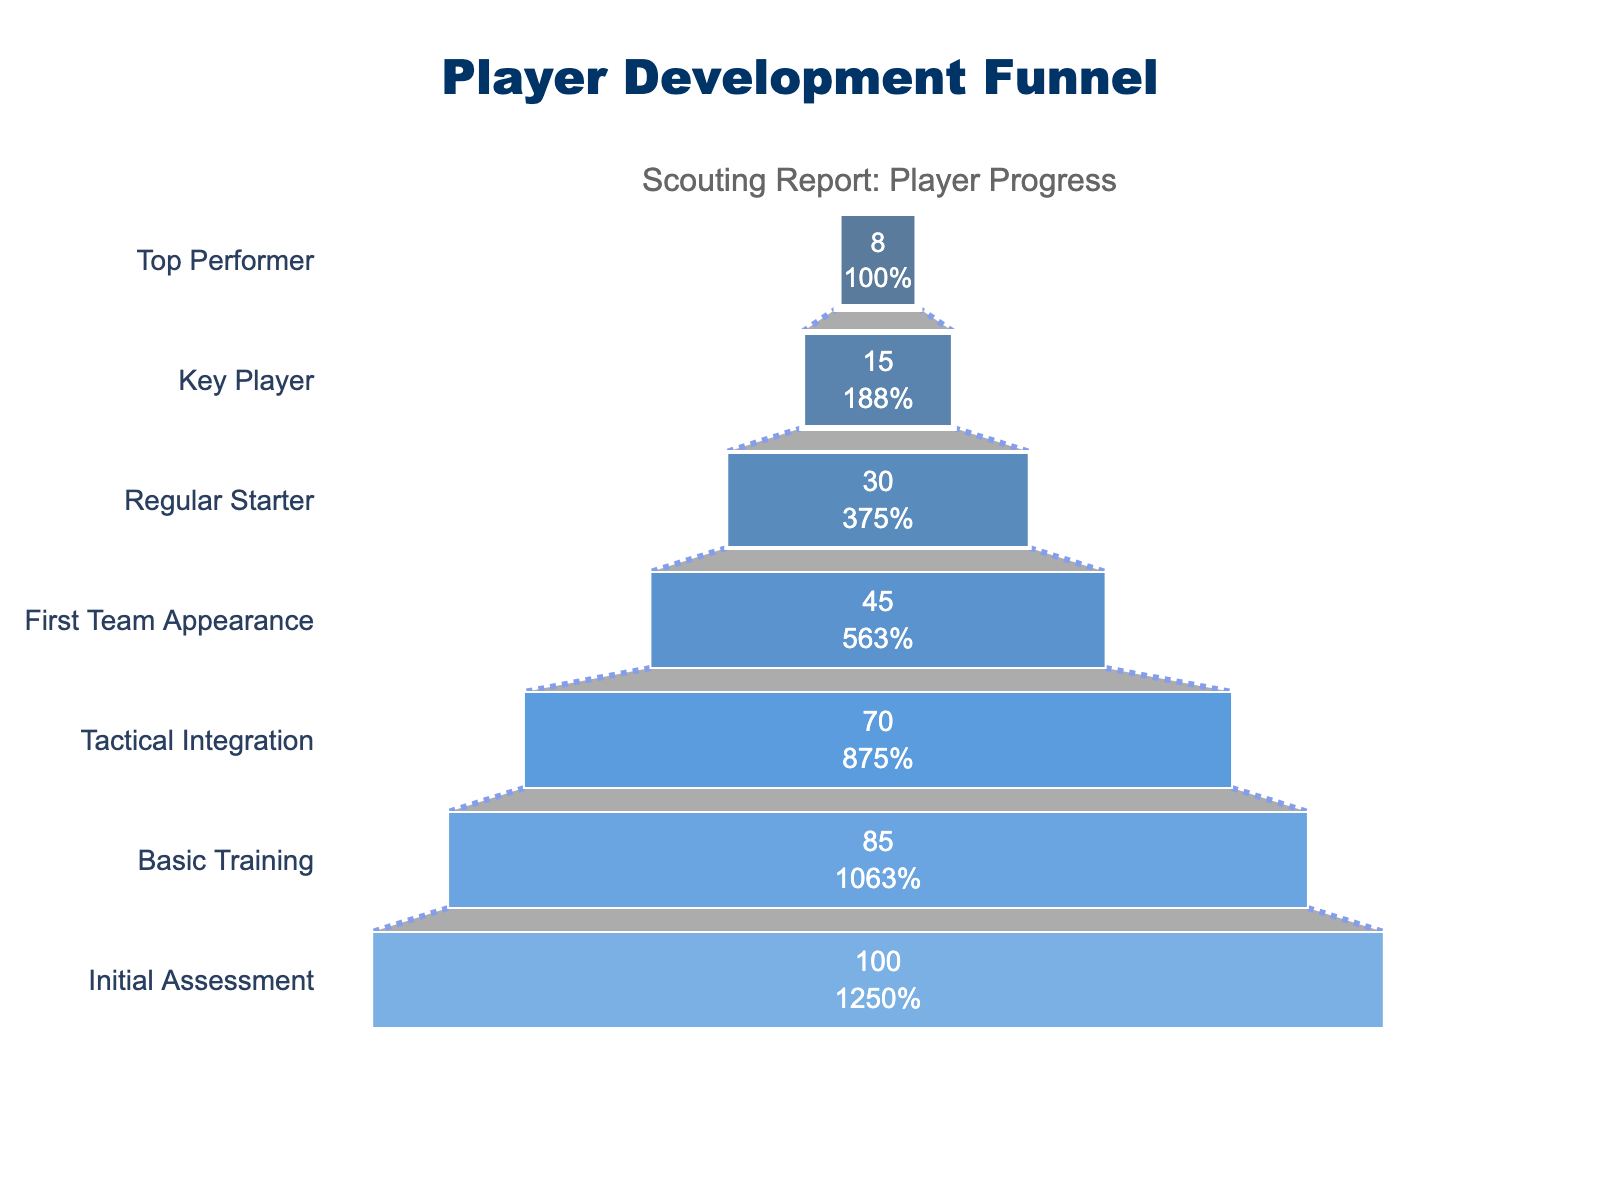What is the title of the figure? The title of the figure is typically located at the top. In this case, the title is "Player Development Funnel," as stated in the code.
Answer: Player Development Funnel How many players start in the "Initial Assessment" stage? The number of players at each stage is shown next to the stage name. For the "Initial Assessment," it's 100 players.
Answer: 100 What percentage of players make it from "First Team Appearance" to "Regular Starter"? We need to find the percentage of players moving from 45 to 30. The formula is (30/45) * 100%.
Answer: 66.67% How many more players are there in the "Key Player" stage compared to the "Top Performer" stage? We need to subtract the number of players in the "Top Performer" stage (8) from the number in the "Key Player" stage (15).
Answer: 7 Which stage sees the most significant decrease in the number of players? By comparing all successive stages, the transition from "Tactical Integration" (70) to "First Team Appearance" (45) shows the largest drop, which is 25 players.
Answer: Tactical Integration to First Team Appearance What is the difference in the number of players between the "Basic Training" and the "Key Player" stages? Subtract the number of players in the "Key Player" stage (15) from those in the "Basic Training" stage (85).
Answer: 70 What percentage of players reached the "Top Performer" stage from the initial number? The initial number is 100 players, and 8 make it to the "Top Performer" stage. The percentage is (8/100) * 100%.
Answer: 8% How many stages do more than 50% of players successfully progress through? We need to identify stages with 50% or more players progressing. Since 50% of 100 is 50, only "Initial Assessment" (100), "Basic Training" (85), and "Tactical Integration" (70) have more than 50 players. So, it's only the first two stages beyond "Initial Assessment."
Answer: 2 In terms of player retention, which stage retains the highest percentage of its previous stage? Calculating percentages for each drop, "Basic Training" retains (85/100) = 85%, "Tactical Integration" retains (70/85) = 82.35%, "First Team Appearance" retains (45/70) = 64.29%, "Regular Starter" retains (30/45) = 66.67%, "Key Player" retains (15/30) = 50%, and "Top Performer" retains (8/15) = 53.33%. "Basic Training" has the highest retention rate.
Answer: Basic Training 